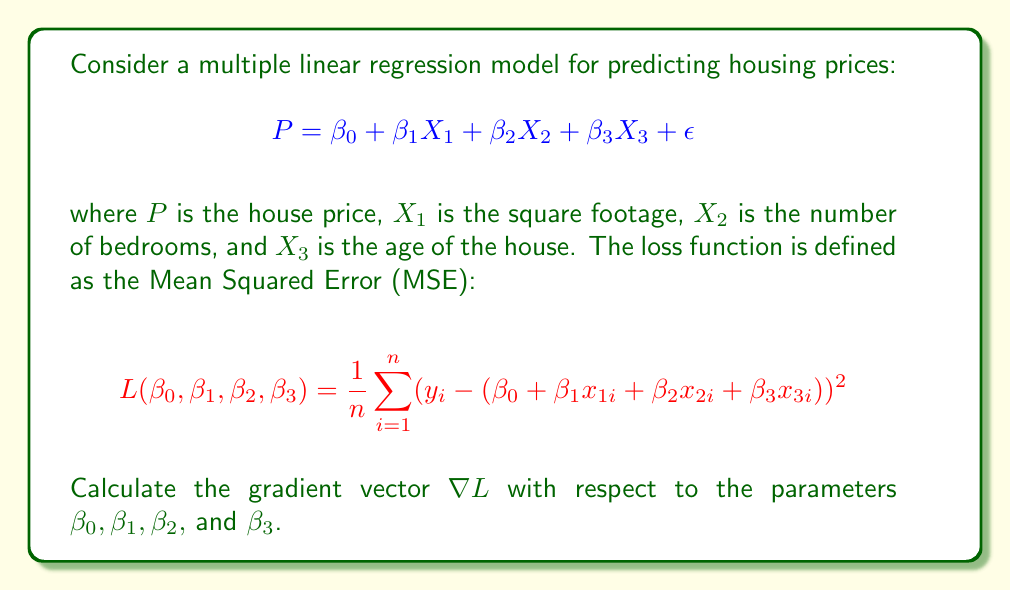Help me with this question. To find the gradient vector, we need to calculate the partial derivatives of the loss function with respect to each parameter. Let's do this step-by-step:

1) First, let's expand the squared term in the loss function:
   $$L = \frac{1}{n}\sum_{i=1}^n (y_i^2 - 2y_i(\beta_0 + \beta_1x_{1i} + \beta_2x_{2i} + \beta_3x_{3i}) + (\beta_0 + \beta_1x_{1i} + \beta_2x_{2i} + \beta_3x_{3i})^2)$$

2) Now, let's calculate each partial derivative:

   a) For $\beta_0$:
      $$\frac{\partial L}{\partial \beta_0} = \frac{1}{n}\sum_{i=1}^n (-2y_i + 2(\beta_0 + \beta_1x_{1i} + \beta_2x_{2i} + \beta_3x_{3i}))$$
      $$= \frac{2}{n}\sum_{i=1}^n (\beta_0 + \beta_1x_{1i} + \beta_2x_{2i} + \beta_3x_{3i} - y_i)$$

   b) For $\beta_1$:
      $$\frac{\partial L}{\partial \beta_1} = \frac{1}{n}\sum_{i=1}^n (-2y_ix_{1i} + 2x_{1i}(\beta_0 + \beta_1x_{1i} + \beta_2x_{2i} + \beta_3x_{3i}))$$
      $$= \frac{2}{n}\sum_{i=1}^n x_{1i}(\beta_0 + \beta_1x_{1i} + \beta_2x_{2i} + \beta_3x_{3i} - y_i)$$

   c) For $\beta_2$:
      $$\frac{\partial L}{\partial \beta_2} = \frac{2}{n}\sum_{i=1}^n x_{2i}(\beta_0 + \beta_1x_{1i} + \beta_2x_{2i} + \beta_3x_{3i} - y_i)$$

   d) For $\beta_3$:
      $$\frac{\partial L}{\partial \beta_3} = \frac{2}{n}\sum_{i=1}^n x_{3i}(\beta_0 + \beta_1x_{1i} + \beta_2x_{2i} + \beta_3x_{3i} - y_i)$$

3) The gradient vector is the collection of these partial derivatives:

   $$\nabla L = \begin{bmatrix}
   \frac{\partial L}{\partial \beta_0} \\
   \frac{\partial L}{\partial \beta_1} \\
   \frac{\partial L}{\partial \beta_2} \\
   \frac{\partial L}{\partial \beta_3}
   \end{bmatrix}$$
Answer: $$\nabla L = \frac{2}{n}\sum_{i=1}^n \begin{bmatrix}
1 \\
x_{1i} \\
x_{2i} \\
x_{3i}
\end{bmatrix}(\beta_0 + \beta_1x_{1i} + \beta_2x_{2i} + \beta_3x_{3i} - y_i)$$ 